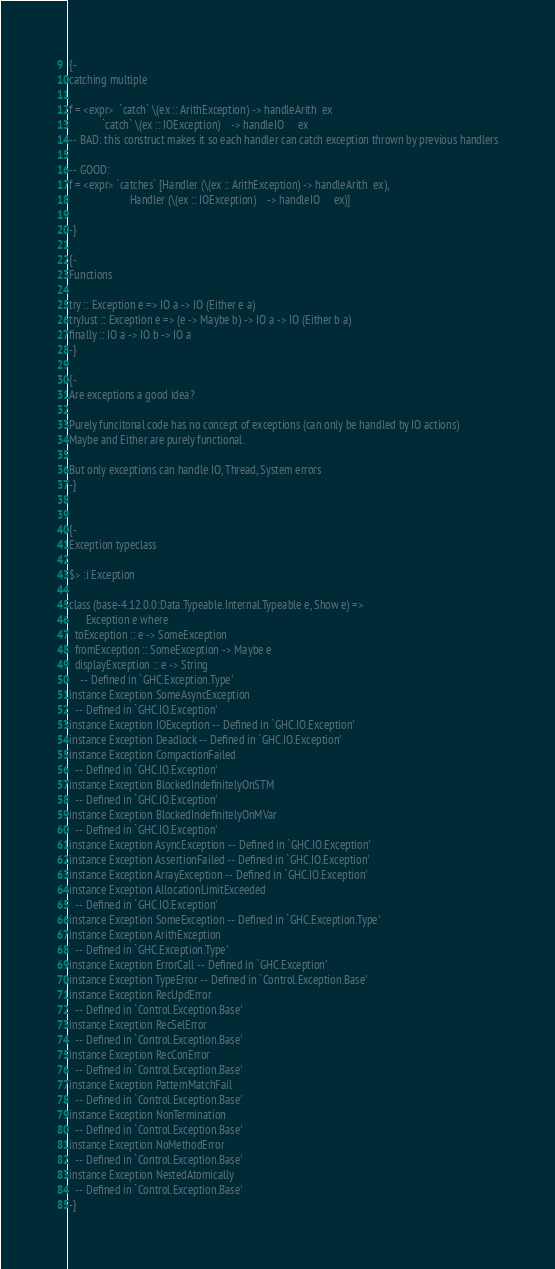<code> <loc_0><loc_0><loc_500><loc_500><_Haskell_>
{-
catching multiple

f = <expr>  `catch` \(ex :: ArithException) -> handleArith  ex
            `catch` \(ex :: IOException)    -> handleIO     ex
-- BAD: this construct makes it so each handler can catch exception thrown by previous handlers

-- GOOD:
f = <expr> `catches` [Handler (\(ex :: ArithException) -> handleArith  ex),
                      Handler (\(ex :: IOException)    -> handleIO     ex)]

-}

{-
Functions

try :: Exception e => IO a -> IO (Either e a)
tryJust :: Exception e => (e -> Maybe b) -> IO a -> IO (Either b a)
finally :: IO a -> IO b -> IO a
-}

{-
Are exceptions a good idea?

Purely funcitonal code has no concept of exceptions (can only be handled by IO actions)
Maybe and Either are purely functional.

But only exceptions can handle IO, Thread, System errors
-}


{-
Exception typeclass

$> :i Exception

class (base-4.12.0.0:Data.Typeable.Internal.Typeable e, Show e) =>
      Exception e where
  toException :: e -> SomeException
  fromException :: SomeException -> Maybe e
  displayException :: e -> String
  	-- Defined in `GHC.Exception.Type'
instance Exception SomeAsyncException
  -- Defined in `GHC.IO.Exception'
instance Exception IOException -- Defined in `GHC.IO.Exception'
instance Exception Deadlock -- Defined in `GHC.IO.Exception'
instance Exception CompactionFailed
  -- Defined in `GHC.IO.Exception'
instance Exception BlockedIndefinitelyOnSTM
  -- Defined in `GHC.IO.Exception'
instance Exception BlockedIndefinitelyOnMVar
  -- Defined in `GHC.IO.Exception'
instance Exception AsyncException -- Defined in `GHC.IO.Exception'
instance Exception AssertionFailed -- Defined in `GHC.IO.Exception'
instance Exception ArrayException -- Defined in `GHC.IO.Exception'
instance Exception AllocationLimitExceeded
  -- Defined in `GHC.IO.Exception'
instance Exception SomeException -- Defined in `GHC.Exception.Type'
instance Exception ArithException
  -- Defined in `GHC.Exception.Type'
instance Exception ErrorCall -- Defined in `GHC.Exception'
instance Exception TypeError -- Defined in `Control.Exception.Base'
instance Exception RecUpdError
  -- Defined in `Control.Exception.Base'
instance Exception RecSelError
  -- Defined in `Control.Exception.Base'
instance Exception RecConError
  -- Defined in `Control.Exception.Base'
instance Exception PatternMatchFail
  -- Defined in `Control.Exception.Base'
instance Exception NonTermination
  -- Defined in `Control.Exception.Base'
instance Exception NoMethodError
  -- Defined in `Control.Exception.Base'
instance Exception NestedAtomically
  -- Defined in `Control.Exception.Base'
-}</code> 